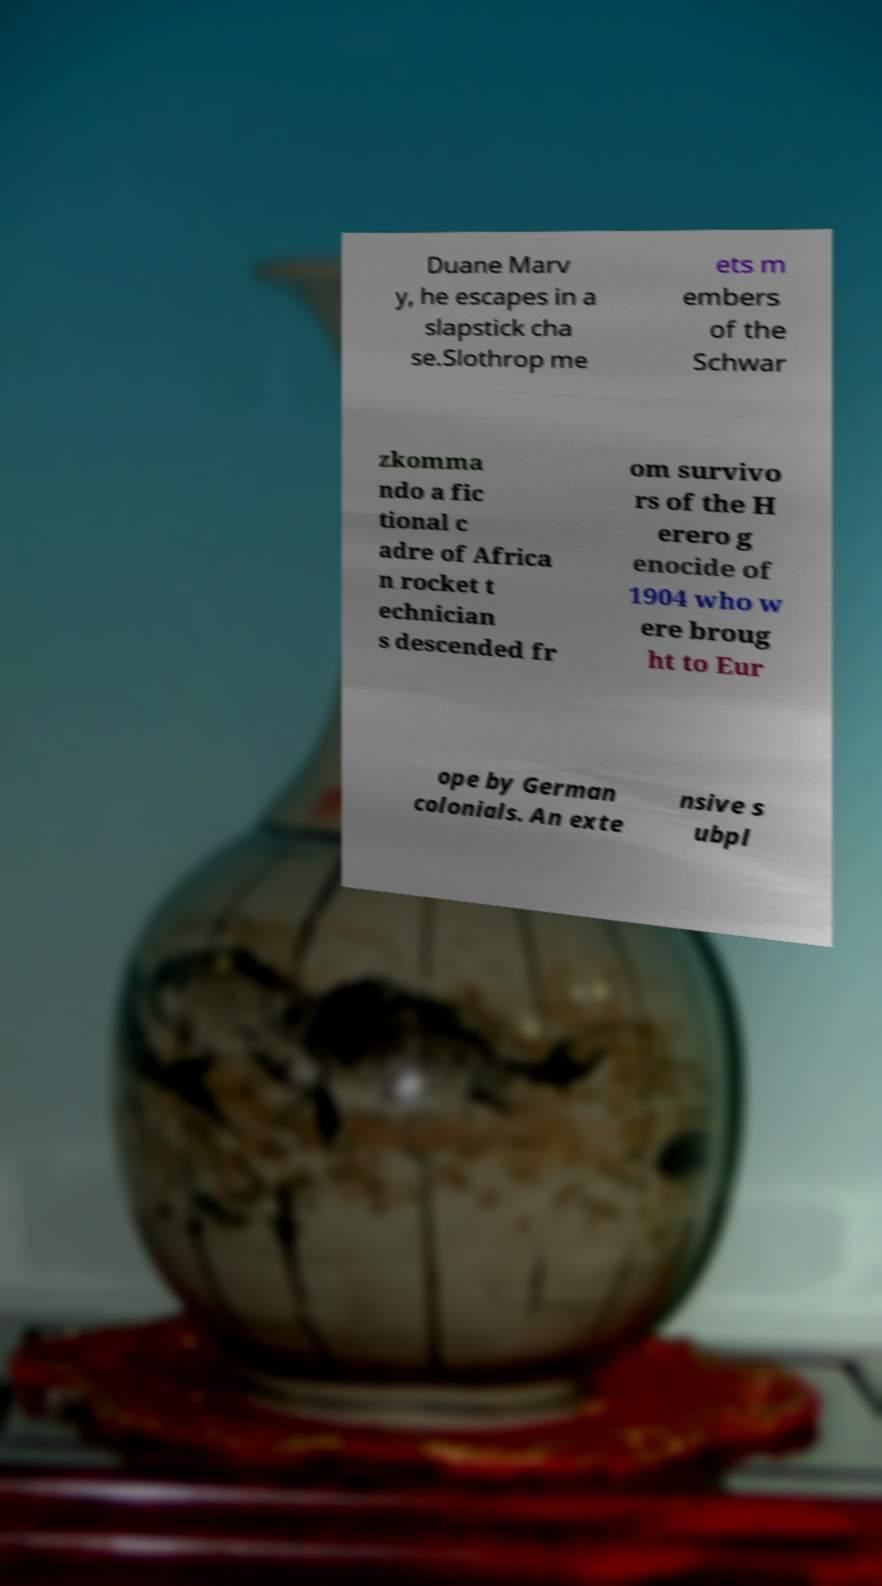Can you accurately transcribe the text from the provided image for me? Duane Marv y, he escapes in a slapstick cha se.Slothrop me ets m embers of the Schwar zkomma ndo a fic tional c adre of Africa n rocket t echnician s descended fr om survivo rs of the H erero g enocide of 1904 who w ere broug ht to Eur ope by German colonials. An exte nsive s ubpl 